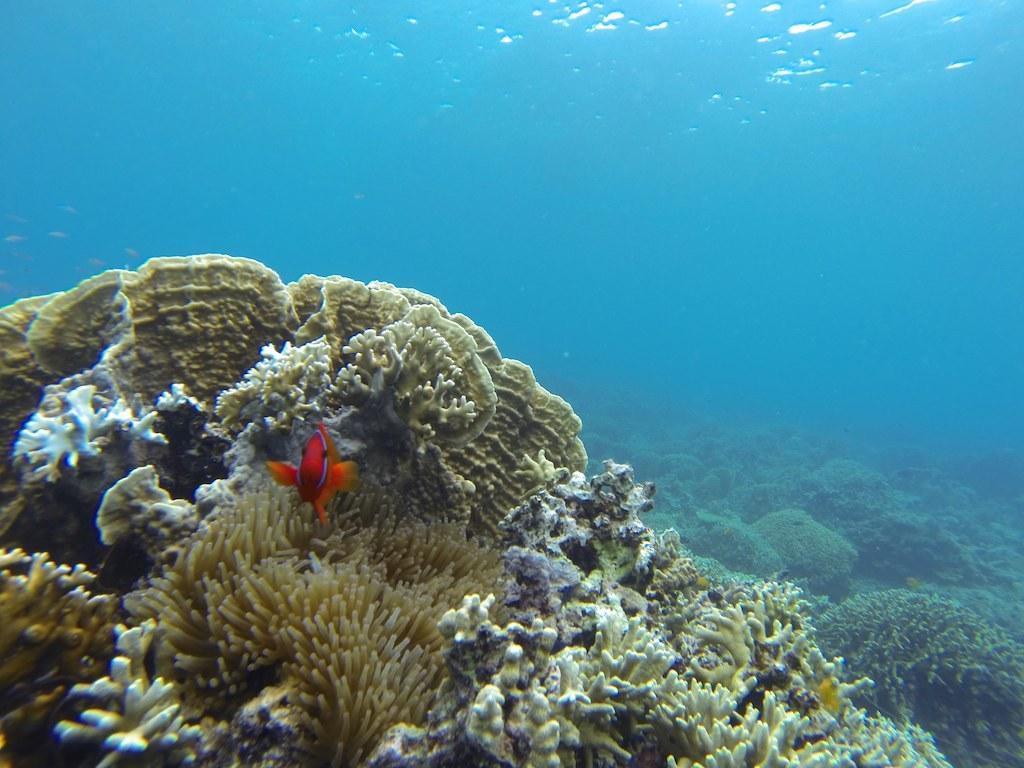Please provide a concise description of this image. In the foreground of this picture, there is a red fish. In the background, there are sea plants under the water. 